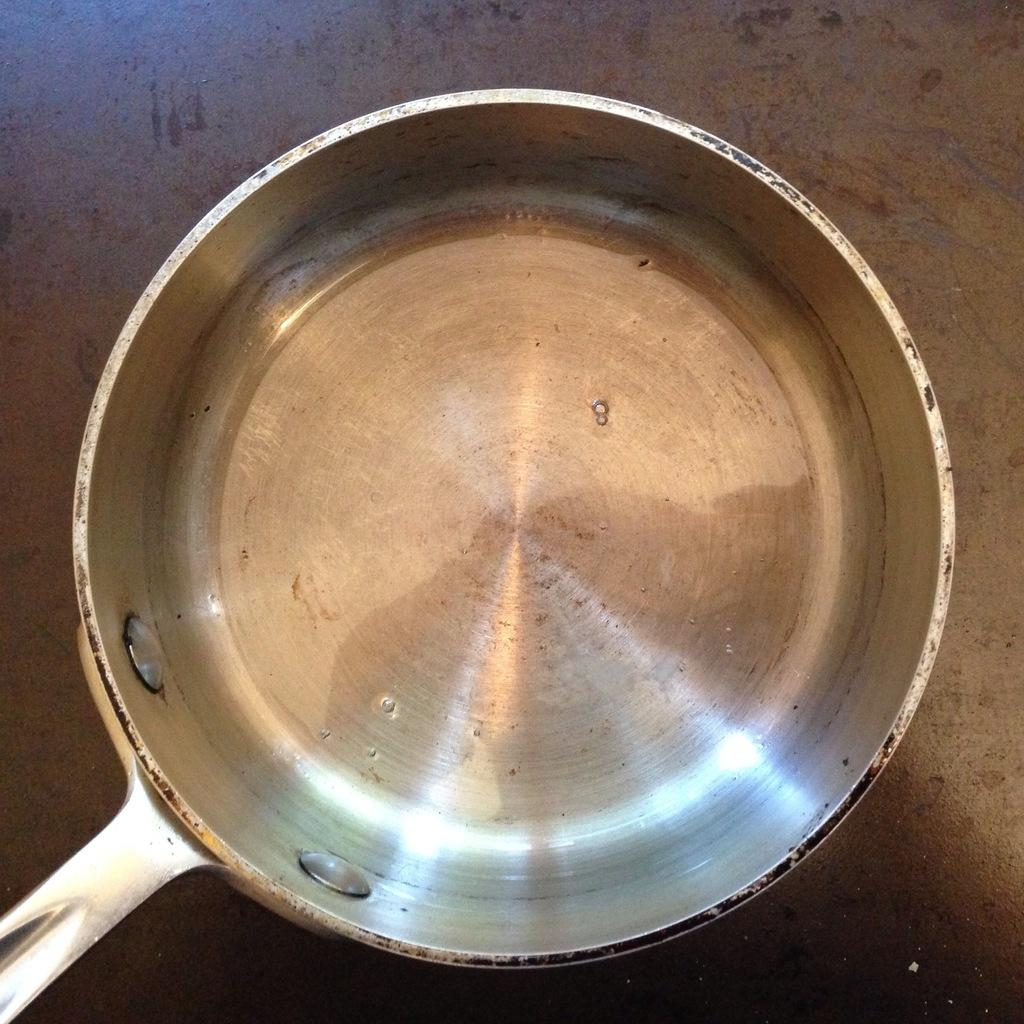What is on the floor in the image? There is a pan on the floor. What type of bomb is hidden inside the pan in the image? There is no bomb present in the image; it is a pan on the floor. What type of pie is being prepared in the pan in the image? There is no pie present in the image; it is a pan on the floor. 